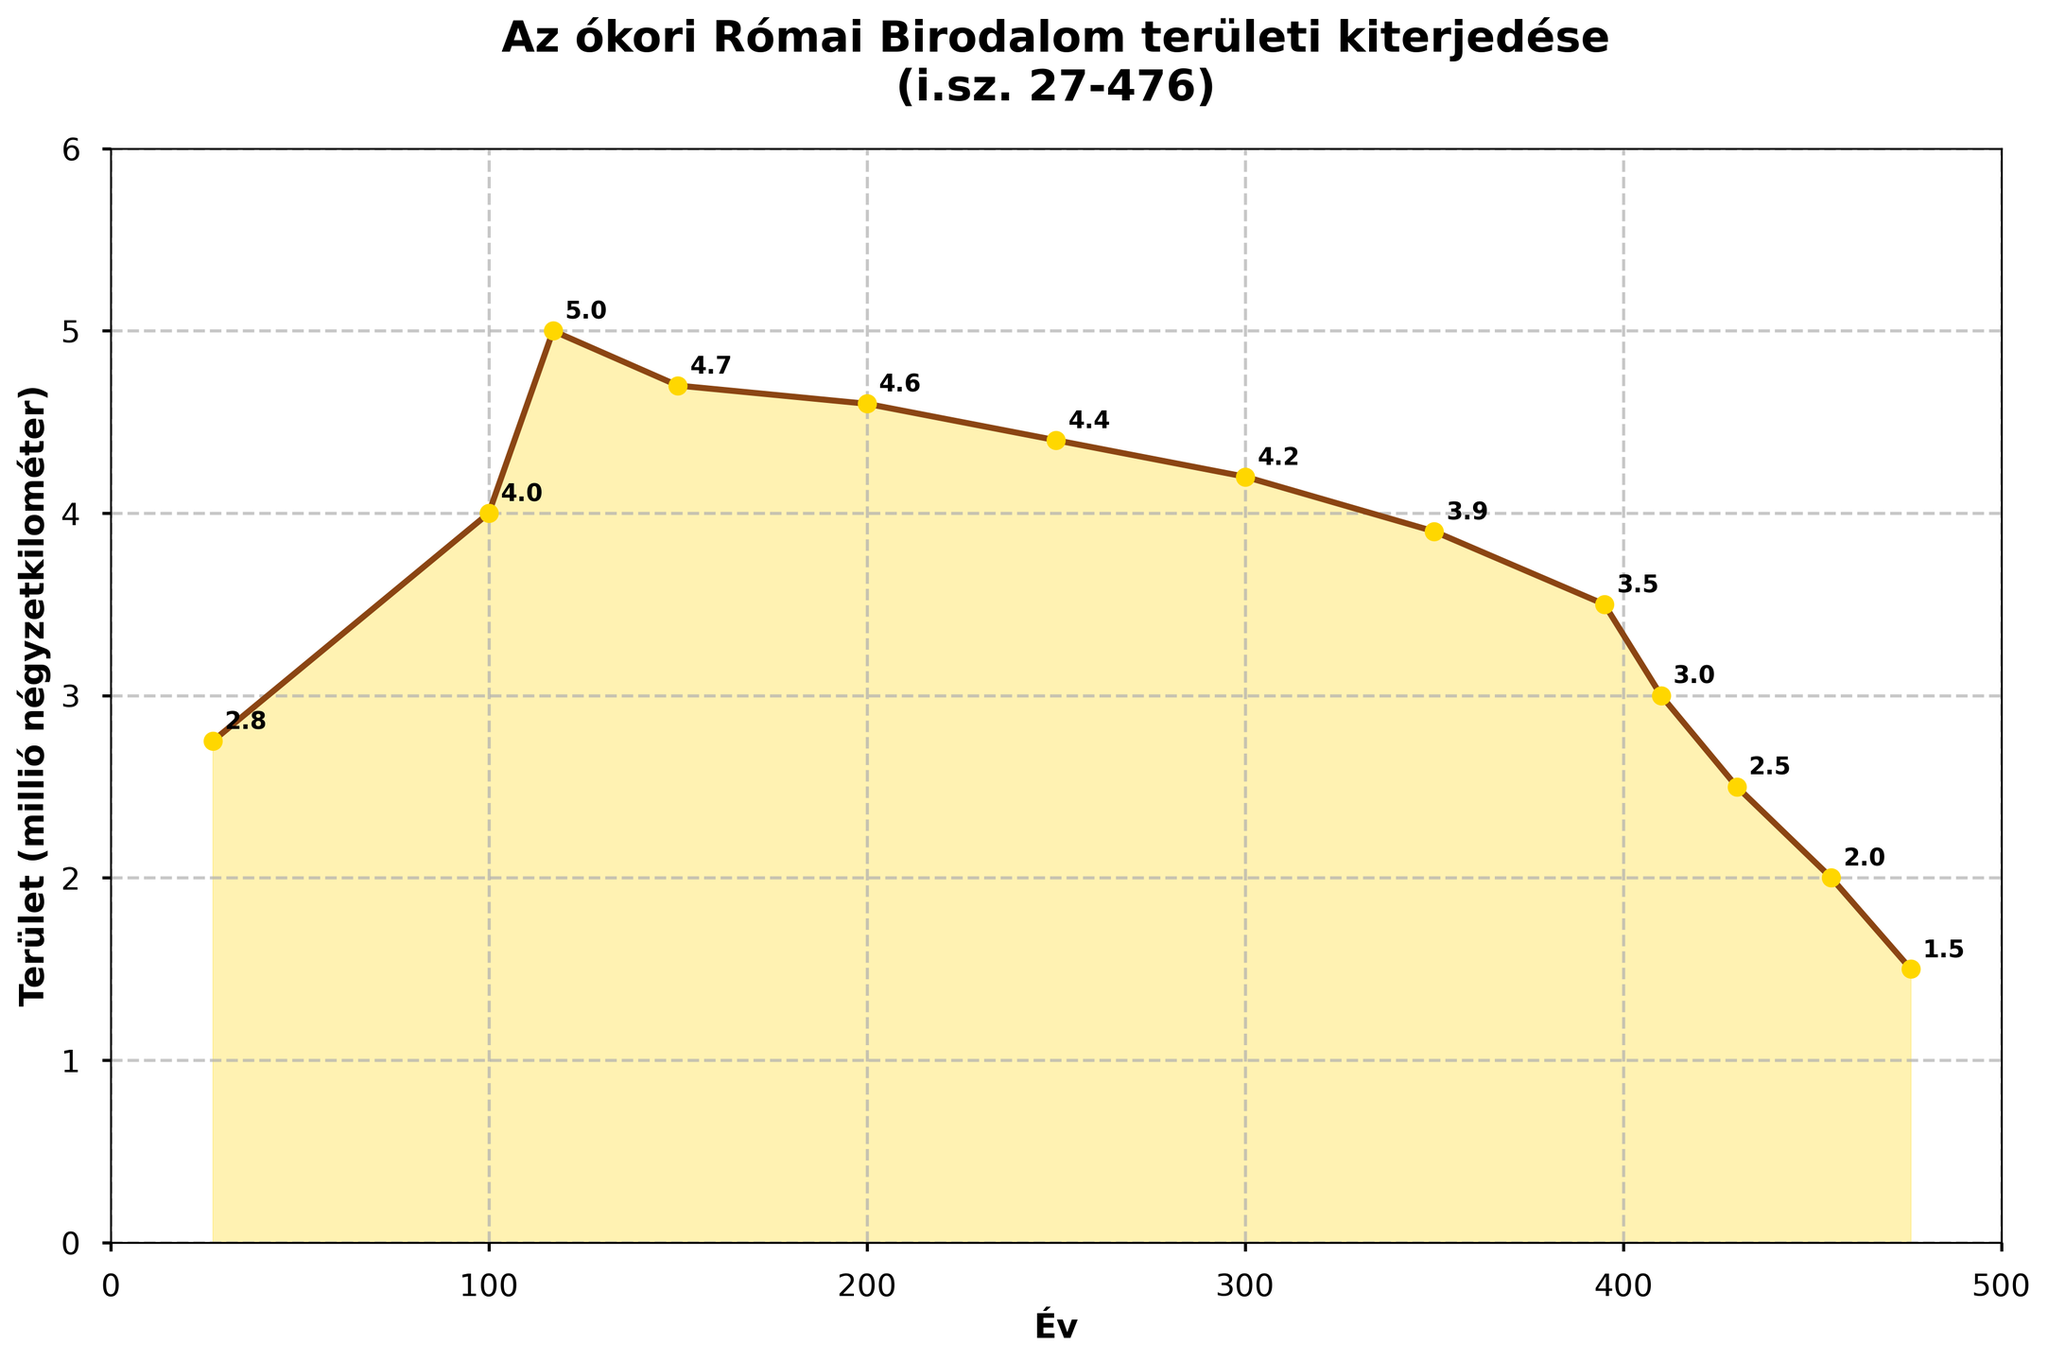What's the year when the Római Birodalom reached its maximum territorial extent? The figure indicates the maximum territorial extent occurred when the territory is the highest. This peak is marked at 117.
Answer: 117 How does the territory size in year 200 compare to that in year 100? In year 100, the territory is 4 million km², and in year 200, it is slightly smaller at 4.6 million km². 200's territory is smaller than 100's.
Answer: 200 is smaller Identify the year with the most rapid decline in territory size. The sharpest decline in the graph is noticeable between 395 (3.5 million km²) and 410 (3 million km²), which indicates the most rapid decline in territory size.
Answer: Between 395 and 410 What's the total decline in territory size from year 117 to 476? The territory size in year 117 is 5 million km², and in year 476 is 1.5 million km². The decline is 5 - 1.5 = 3.5 million km².
Answer: 3.5 million km² What's the general trend of the Római Birodalom's territory size from year 300 to year 476? Observing the graph, the territory size shows a downward trend from 300 (4.2 million km²) to 476 (1.5 million km²), indicating a decline.
Answer: Decline During which period did the Római Birodalom maintain a relatively stable territory size? Between 200 (4.6 million km²) and 300 (4.2 million km²), the territory size remains relatively stable with only small fluctuations.
Answer: 200 to 300 By how much did the territory size shrink between the year 250 and the year 300? The territory size in year 250 is 4.4 million km² and in year 300 is 4.2 million km². The shrinkage is 4.4 - 4.2 = 0.2 million km².
Answer: 0.2 million km² What visual elements are used to highlight the territory sizes at specific years in the plot? The plot uses markers at each data point, annotates these points with the respective values, and a shaded area under the line to make the territory sizes prominent.
Answer: Markers, annotations, and shading What is the approximate average territory size from year 27 to year 150? Territory sizes from 27 to 150 are: 2.75, 4.0, 5.0, 4.7 in million km². Average = (2.75 + 4.0 + 5.0 + 4.7) / 4 = 4.115 million km².
Answer: 4.115 million km² 